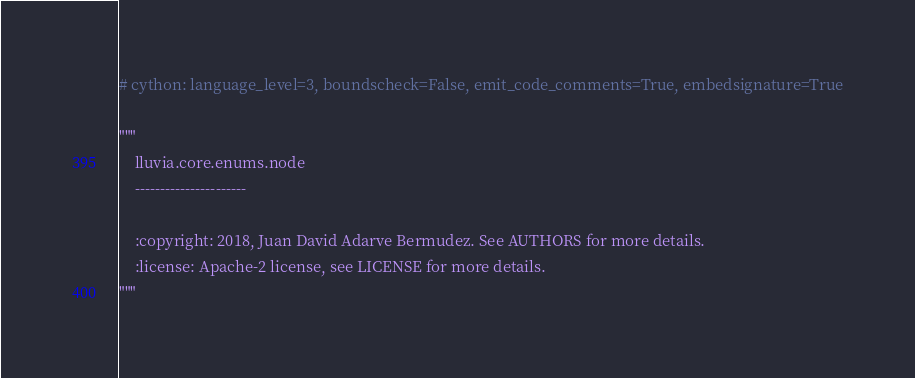<code> <loc_0><loc_0><loc_500><loc_500><_Cython_># cython: language_level=3, boundscheck=False, emit_code_comments=True, embedsignature=True

"""
    lluvia.core.enums.node
    ----------------------

    :copyright: 2018, Juan David Adarve Bermudez. See AUTHORS for more details.
    :license: Apache-2 license, see LICENSE for more details.
"""
</code> 